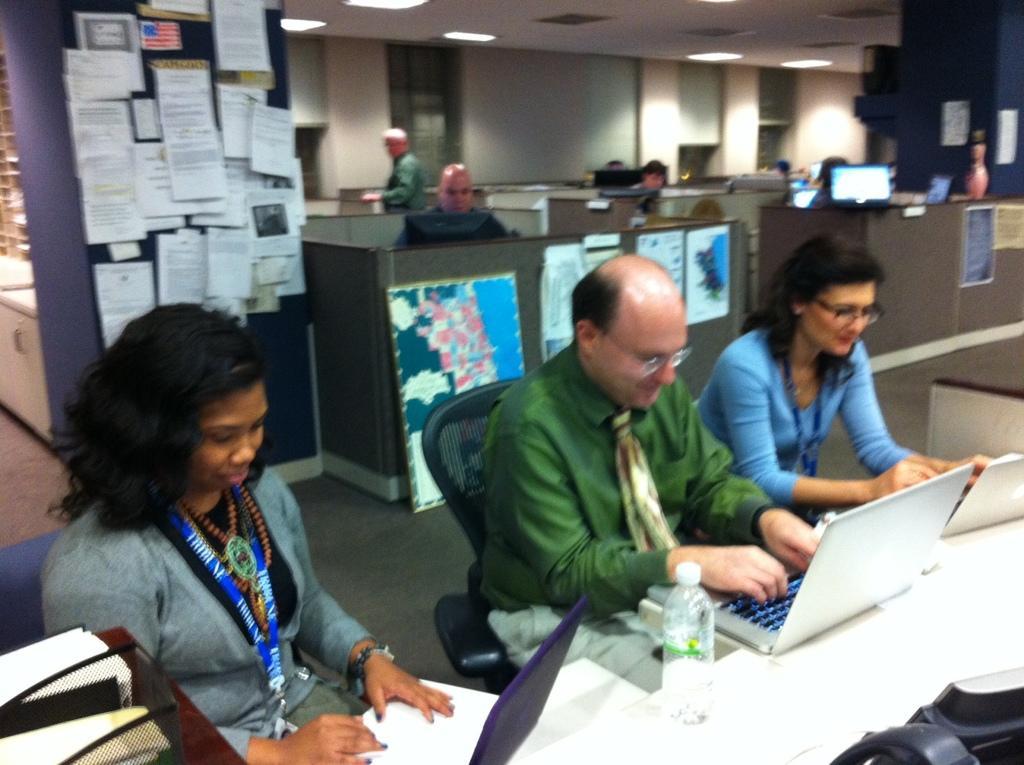How would you summarize this image in a sentence or two? In this image we can see some people sitting on the chairs typing on a keypad. We can also see a bottle and a container on the table. On the backside we can see a wall pasted with papers, a board, windows, wall, a pot, roof and ceiling lights. 